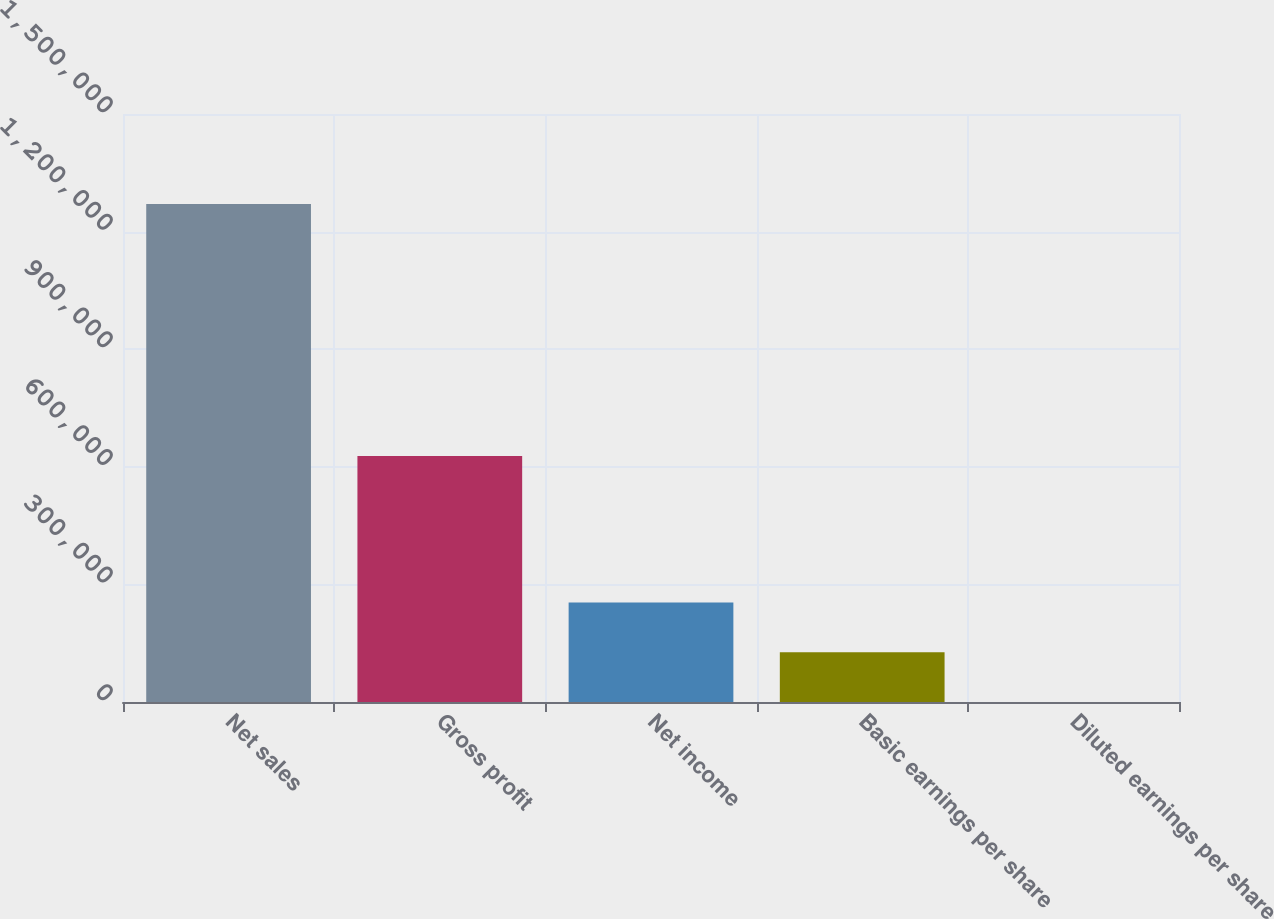Convert chart. <chart><loc_0><loc_0><loc_500><loc_500><bar_chart><fcel>Net sales<fcel>Gross profit<fcel>Net income<fcel>Basic earnings per share<fcel>Diluted earnings per share<nl><fcel>1.27013e+06<fcel>627485<fcel>254026<fcel>127014<fcel>0.57<nl></chart> 